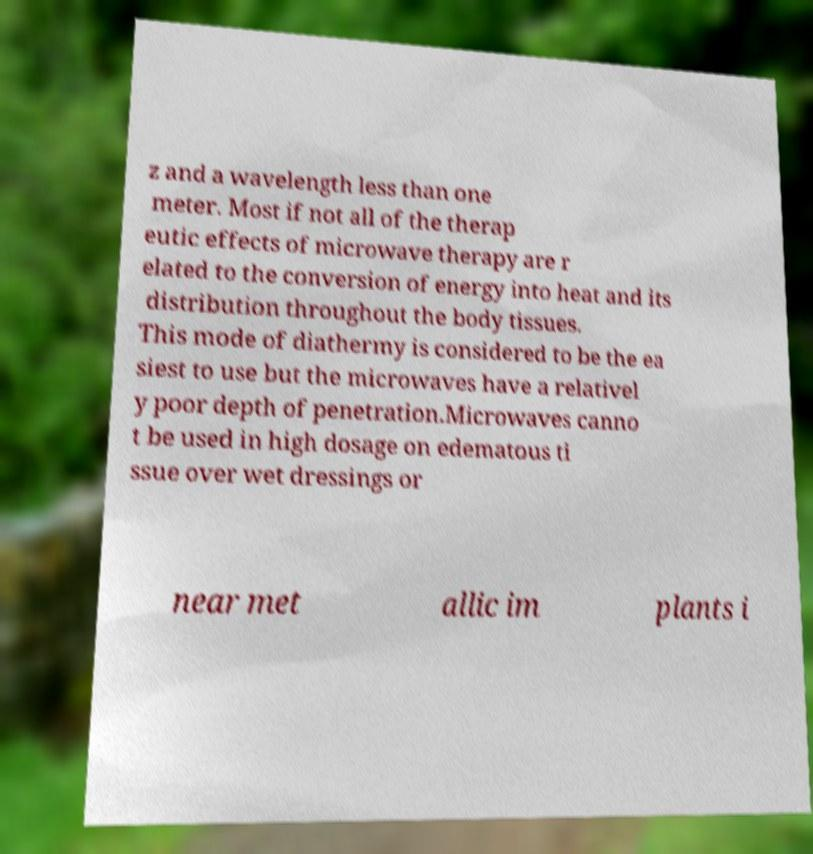Could you assist in decoding the text presented in this image and type it out clearly? z and a wavelength less than one meter. Most if not all of the therap eutic effects of microwave therapy are r elated to the conversion of energy into heat and its distribution throughout the body tissues. This mode of diathermy is considered to be the ea siest to use but the microwaves have a relativel y poor depth of penetration.Microwaves canno t be used in high dosage on edematous ti ssue over wet dressings or near met allic im plants i 